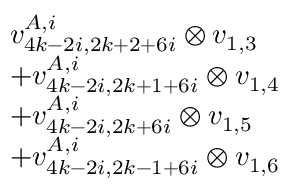<formula> <loc_0><loc_0><loc_500><loc_500>\begin{array} { r l } & { v _ { 4 k - 2 i , 2 k + 2 + 6 i } ^ { A , i } \otimes v _ { 1 , 3 } } \\ & { + v _ { 4 k - 2 i , 2 k + 1 + 6 i } ^ { A , i } \otimes v _ { 1 , 4 } } \\ & { + v _ { 4 k - 2 i , 2 k + 6 i } ^ { A , i } \otimes v _ { 1 , 5 } } \\ & { + v _ { 4 k - 2 i , 2 k - 1 + 6 i } ^ { A , i } \otimes v _ { 1 , 6 } } \end{array}</formula> 